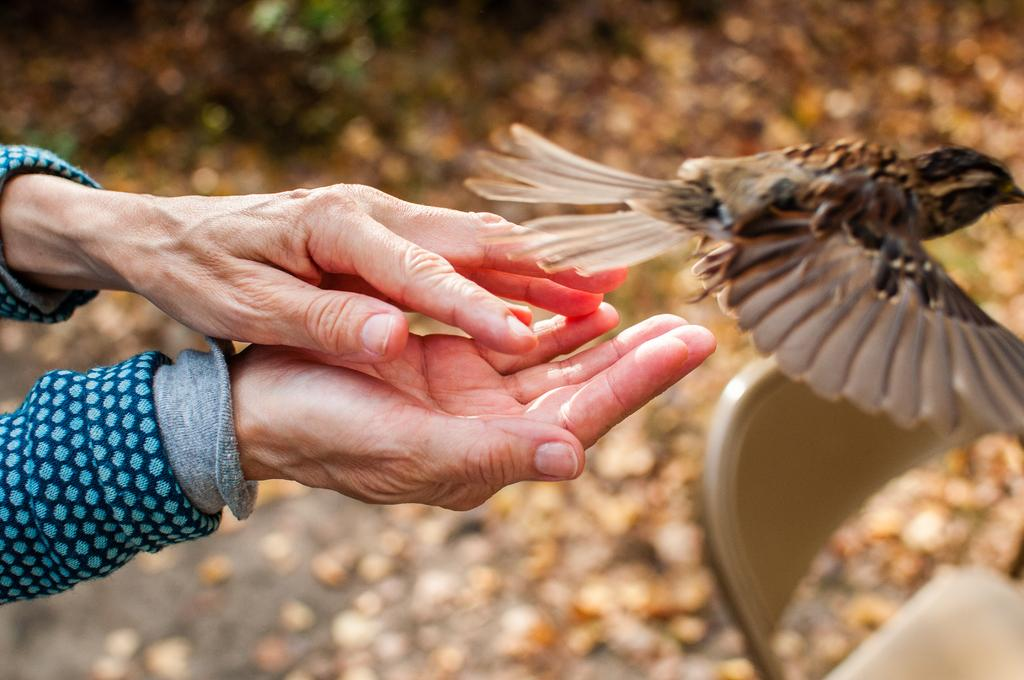What can be seen in the left corner of the image? There are hands of a person in the left corner of the image. What is located in the right corner of the image? There is a bird in the right corner of the image. Can you describe the background of the image? There are other objects present in the background of the image. What is the shape of the temper in the image? There is no temper present in the image, as it is not a physical object or attribute that can be observed. 